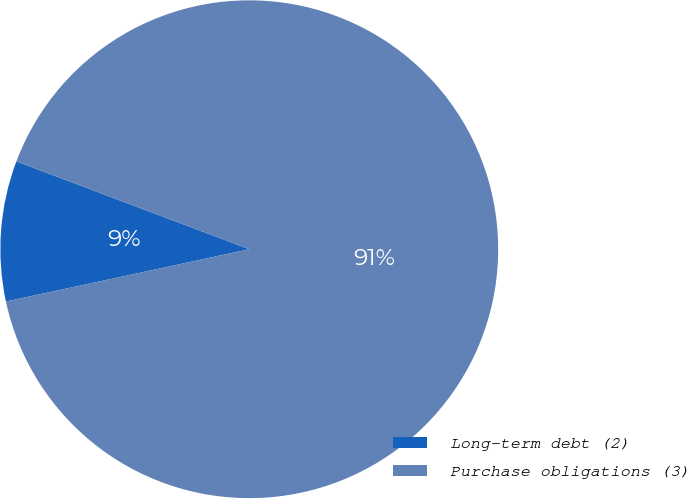Convert chart. <chart><loc_0><loc_0><loc_500><loc_500><pie_chart><fcel>Long-term debt (2)<fcel>Purchase obligations (3)<nl><fcel>9.11%<fcel>90.89%<nl></chart> 